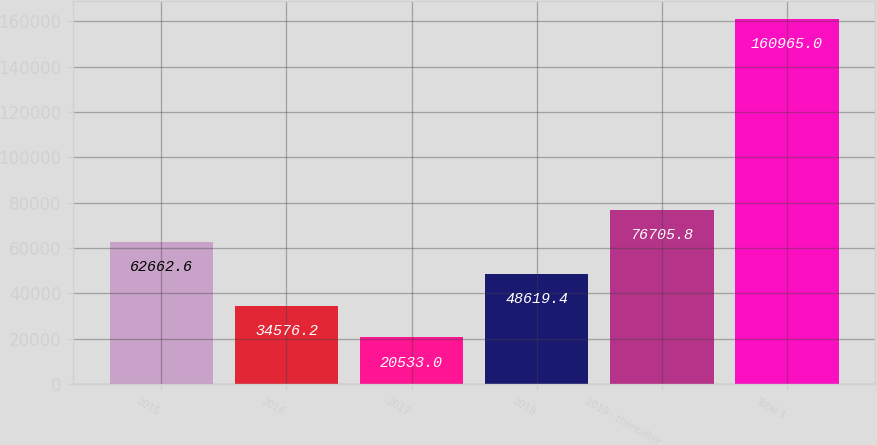<chart> <loc_0><loc_0><loc_500><loc_500><bar_chart><fcel>2015<fcel>2016<fcel>2017<fcel>2018<fcel>2019 - thereafter<fcel>Total 1<nl><fcel>62662.6<fcel>34576.2<fcel>20533<fcel>48619.4<fcel>76705.8<fcel>160965<nl></chart> 